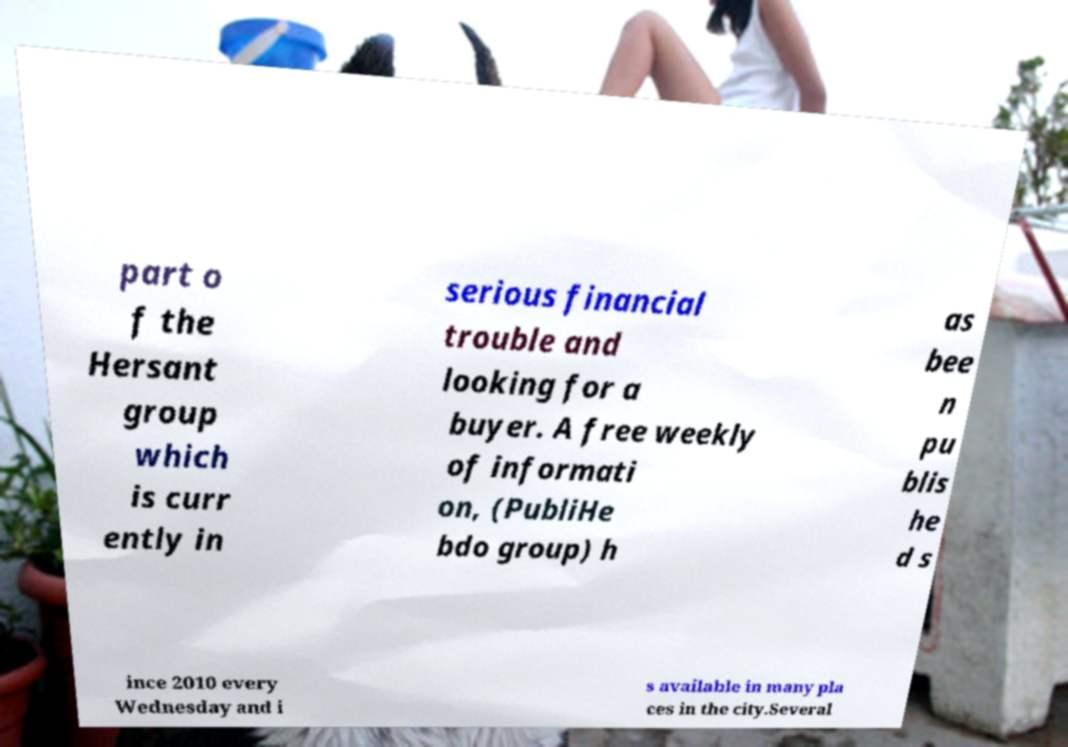I need the written content from this picture converted into text. Can you do that? part o f the Hersant group which is curr ently in serious financial trouble and looking for a buyer. A free weekly of informati on, (PubliHe bdo group) h as bee n pu blis he d s ince 2010 every Wednesday and i s available in many pla ces in the city.Several 